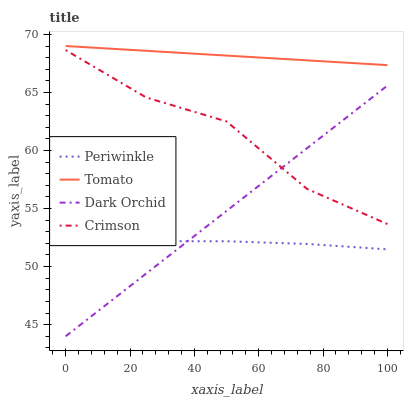Does Crimson have the minimum area under the curve?
Answer yes or no. No. Does Crimson have the maximum area under the curve?
Answer yes or no. No. Is Periwinkle the smoothest?
Answer yes or no. No. Is Periwinkle the roughest?
Answer yes or no. No. Does Crimson have the lowest value?
Answer yes or no. No. Does Crimson have the highest value?
Answer yes or no. No. Is Periwinkle less than Tomato?
Answer yes or no. Yes. Is Tomato greater than Crimson?
Answer yes or no. Yes. Does Periwinkle intersect Tomato?
Answer yes or no. No. 